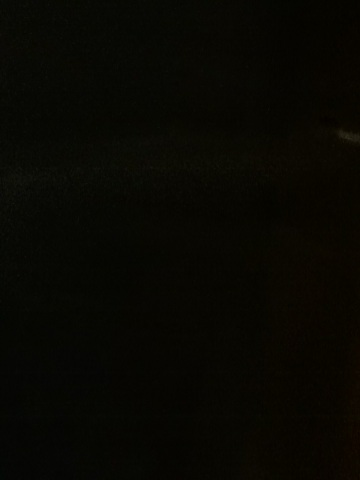How might this image affect the mood of a viewer? Images with such profound darkness can evoke feelings of mystery, suspense, or fear. The lack of visible detail can lead to an interpretation that is influenced by the viewer's imagination and personal experiences. 